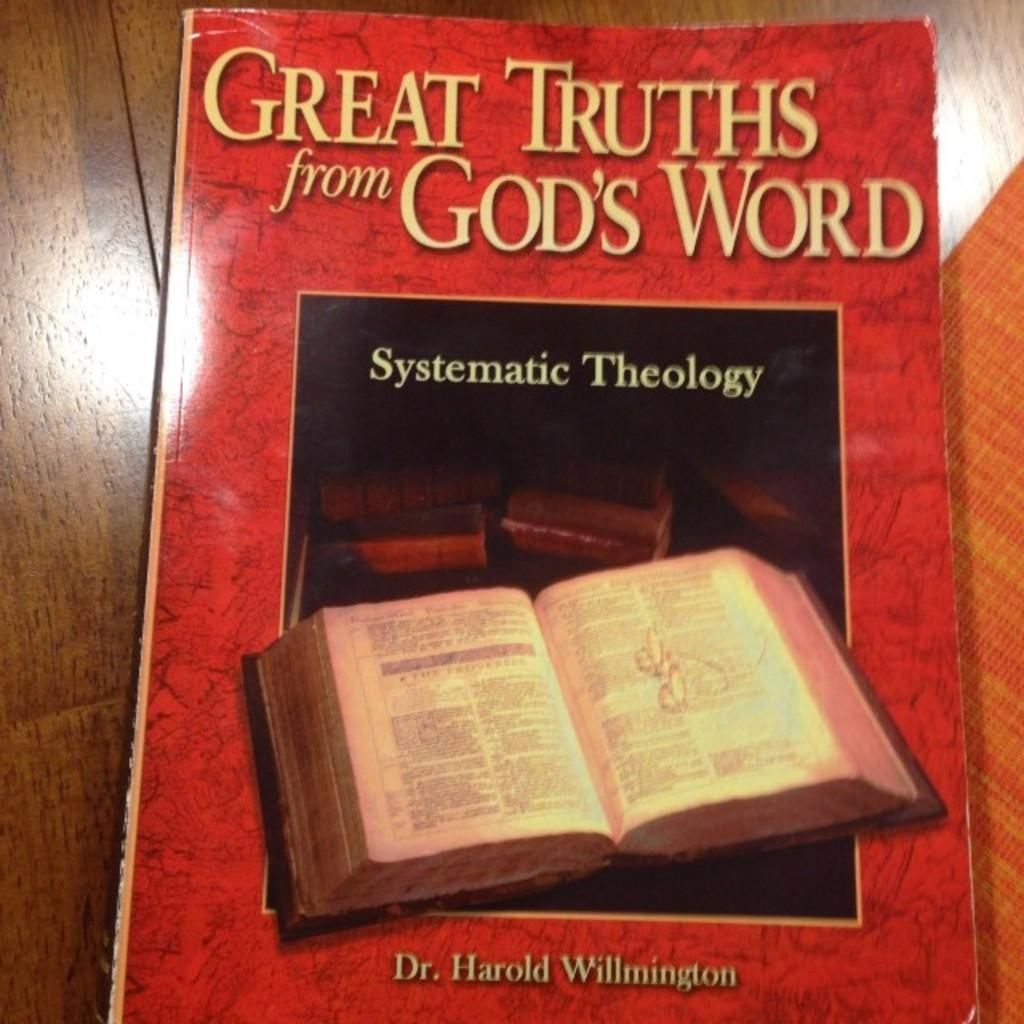<image>
Give a short and clear explanation of the subsequent image. a book about gods word is laying on a table 